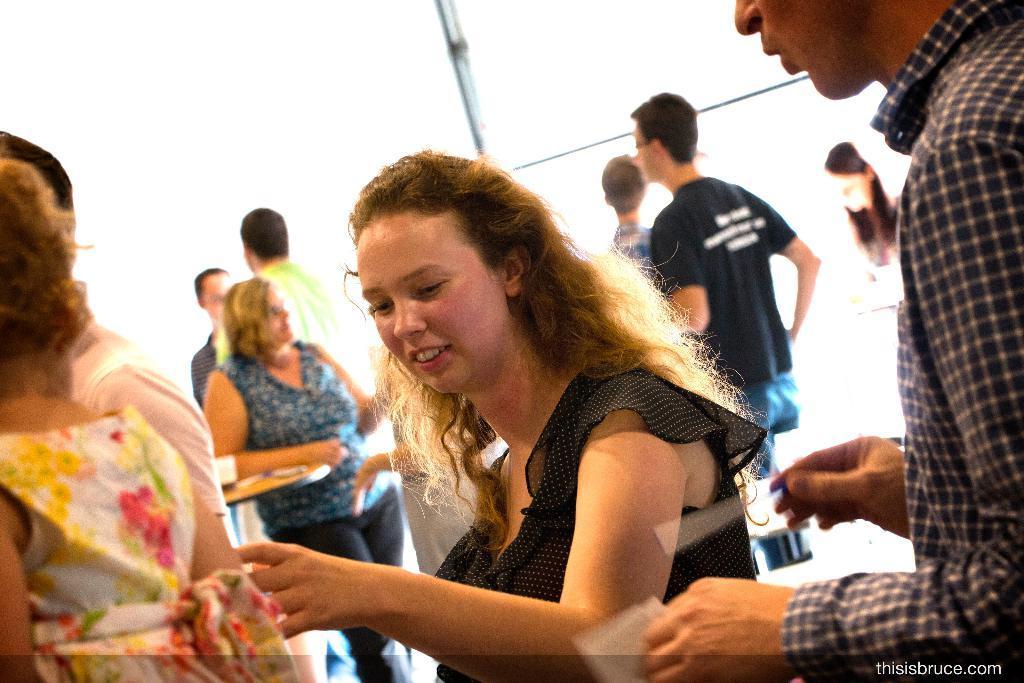Describe this image in one or two sentences. This image consists of many people. In the front, there is a woman wearing a black dress. Beside him, there is a man standing. The background is white in color. 